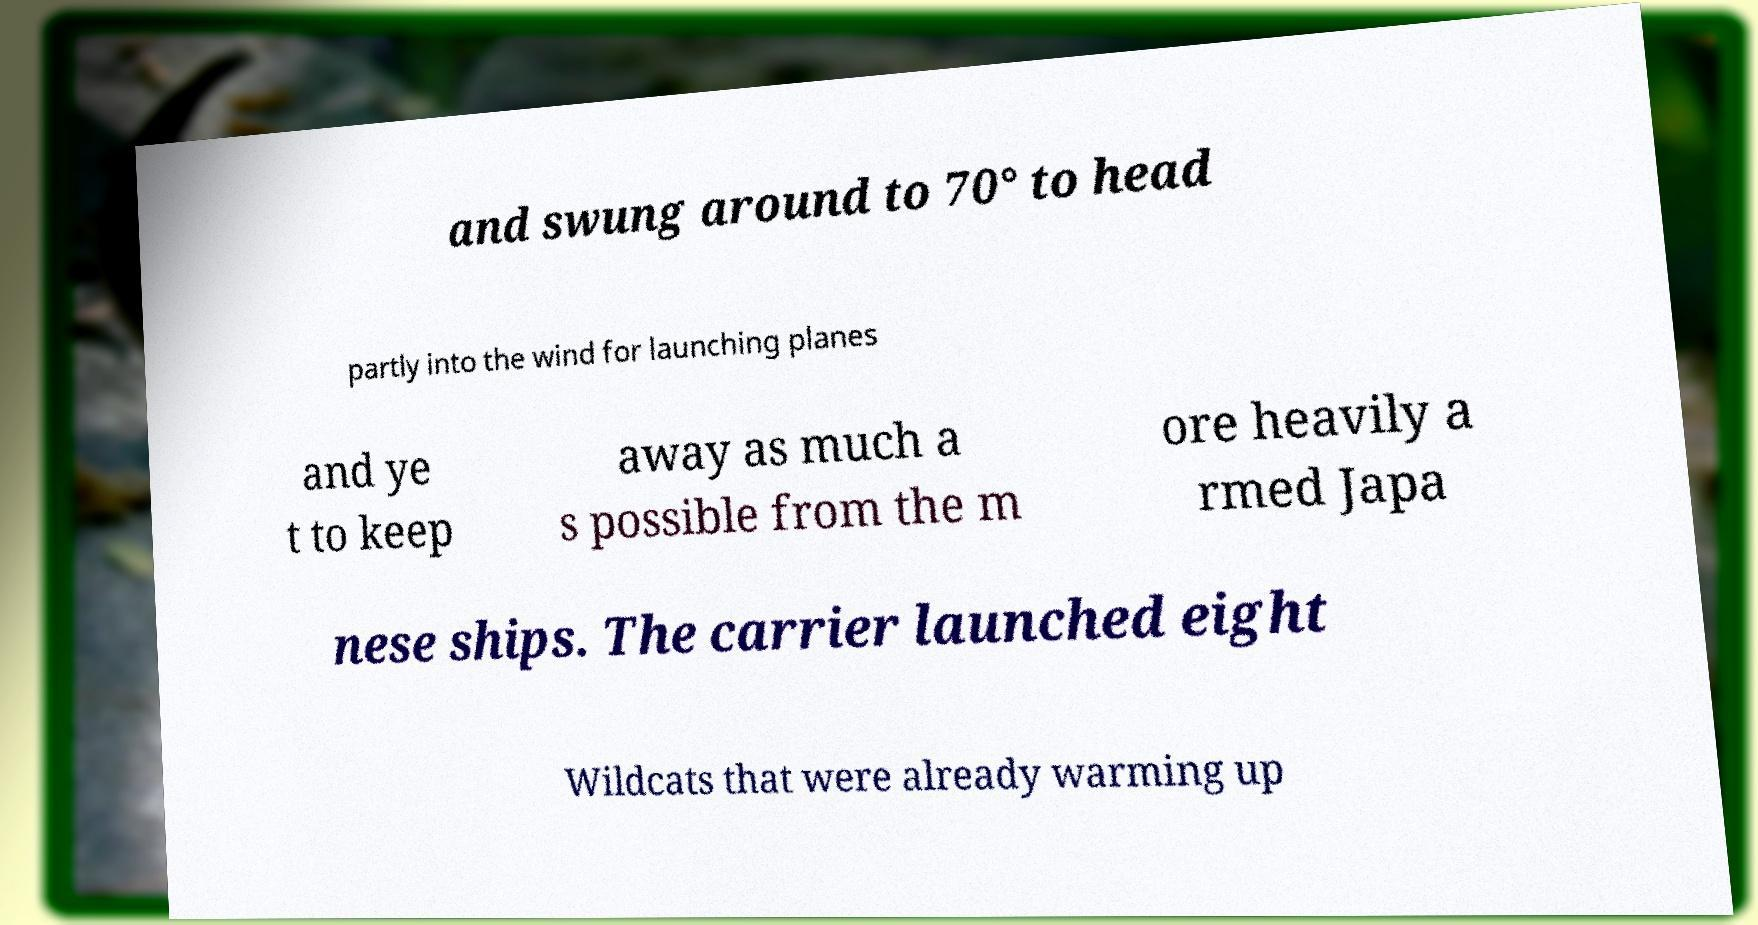Please identify and transcribe the text found in this image. and swung around to 70° to head partly into the wind for launching planes and ye t to keep away as much a s possible from the m ore heavily a rmed Japa nese ships. The carrier launched eight Wildcats that were already warming up 